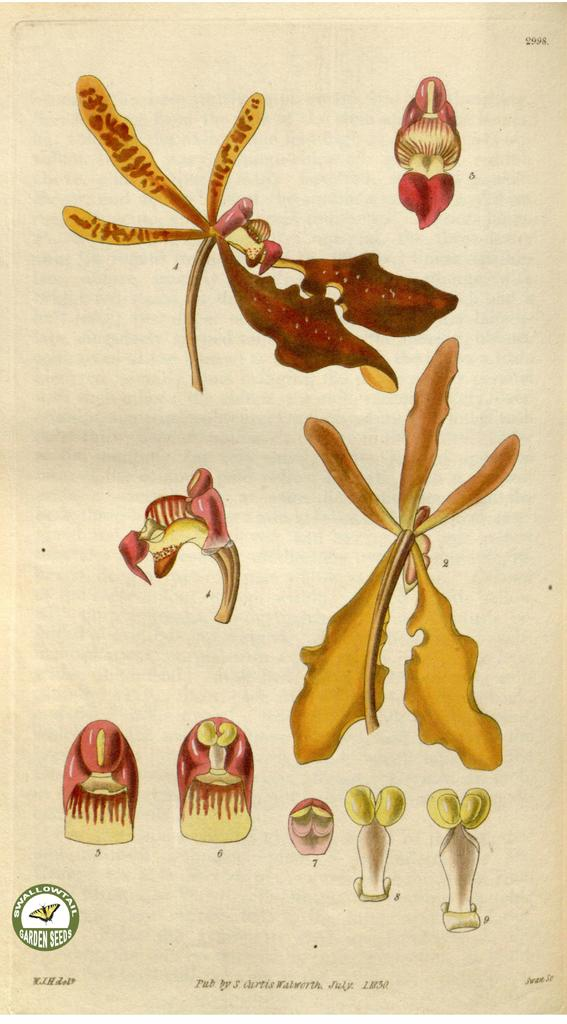What is present on the paper in the image? The paper has an image on it. Is there any text on the paper? Yes, there is text at the bottom of the paper. What type of box is the daughter holding in the image? There is no box or daughter present in the image; it only features a paper with an image and text. 